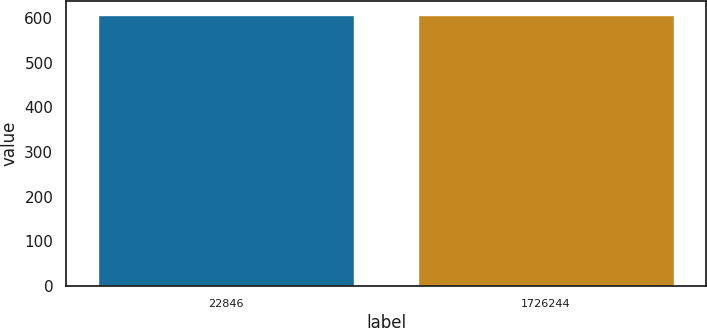<chart> <loc_0><loc_0><loc_500><loc_500><bar_chart><fcel>22846<fcel>1726244<nl><fcel>608<fcel>608.1<nl></chart> 